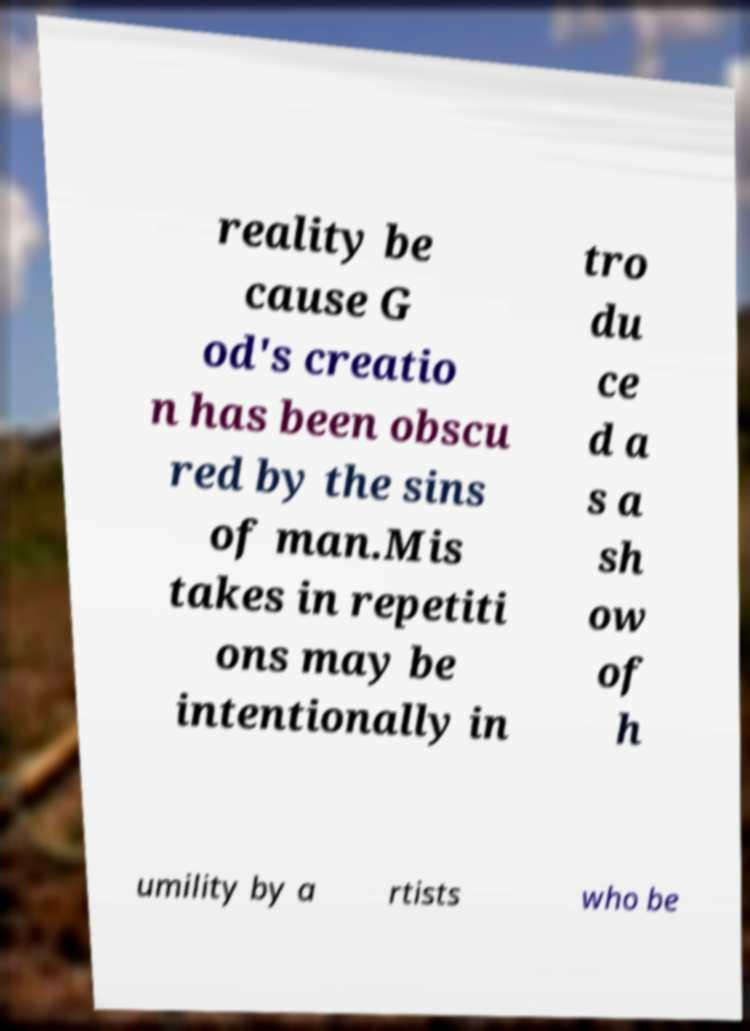What messages or text are displayed in this image? I need them in a readable, typed format. reality be cause G od's creatio n has been obscu red by the sins of man.Mis takes in repetiti ons may be intentionally in tro du ce d a s a sh ow of h umility by a rtists who be 